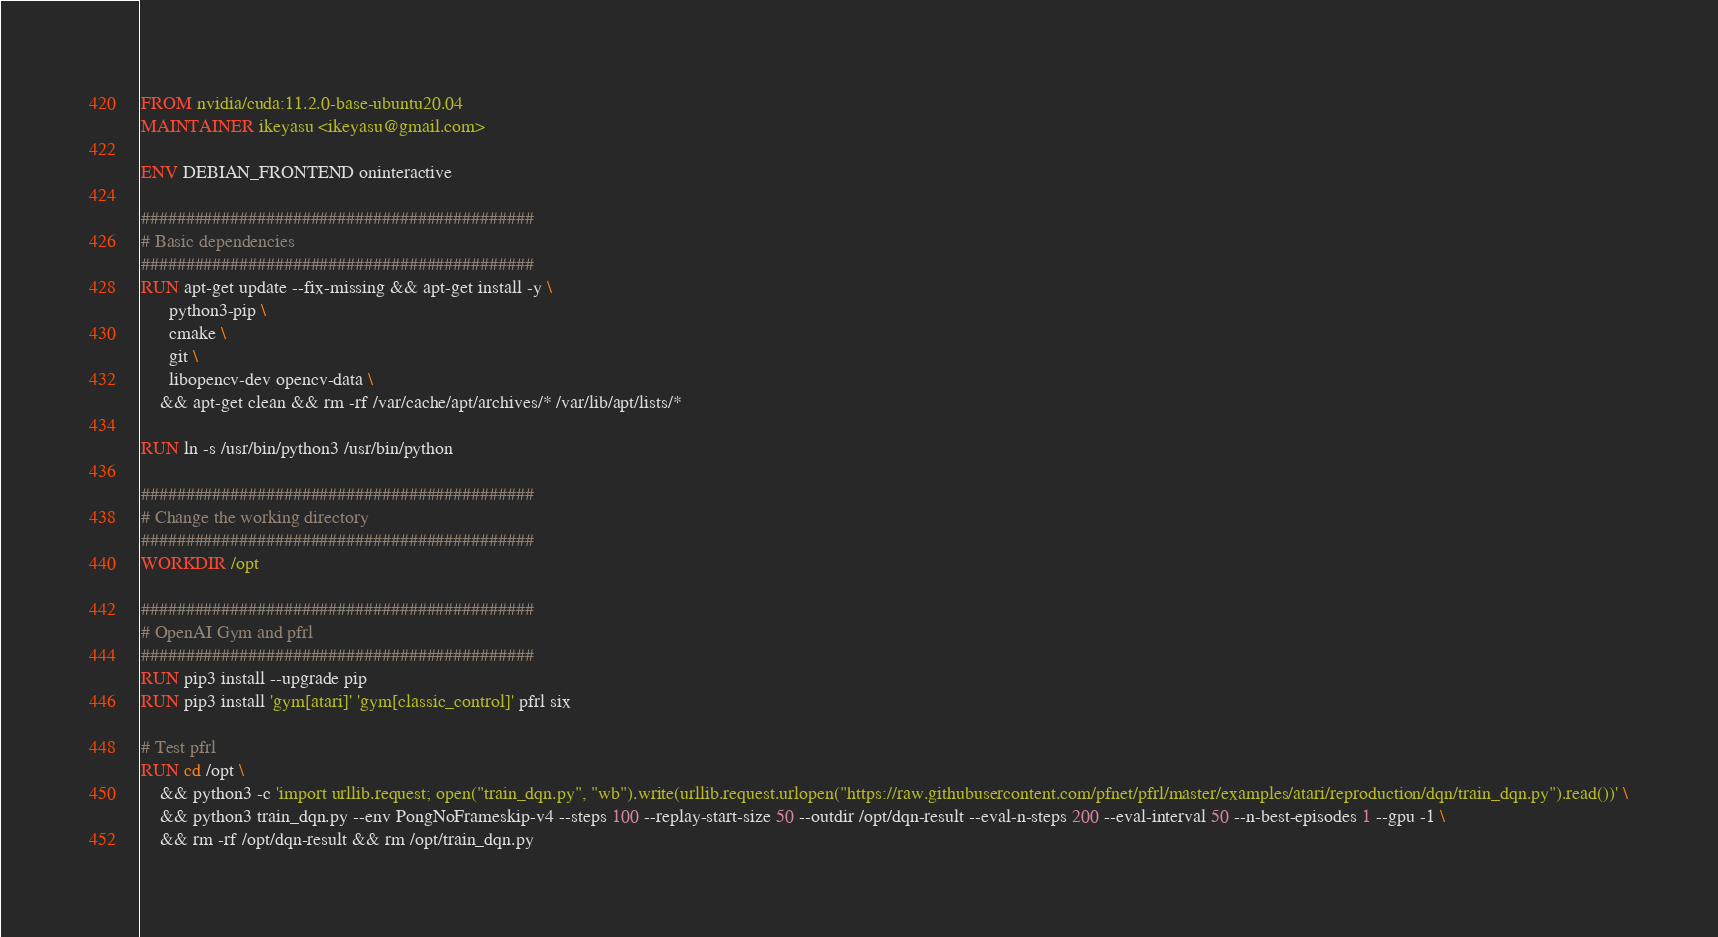<code> <loc_0><loc_0><loc_500><loc_500><_Dockerfile_>FROM nvidia/cuda:11.2.0-base-ubuntu20.04
MAINTAINER ikeyasu <ikeyasu@gmail.com>

ENV DEBIAN_FRONTEND oninteractive

############################################
# Basic dependencies
############################################
RUN apt-get update --fix-missing && apt-get install -y \
      python3-pip \
      cmake \
      git \
      libopencv-dev opencv-data \
    && apt-get clean && rm -rf /var/cache/apt/archives/* /var/lib/apt/lists/*

RUN ln -s /usr/bin/python3 /usr/bin/python

############################################
# Change the working directory
############################################
WORKDIR /opt

############################################
# OpenAI Gym and pfrl 
############################################
RUN pip3 install --upgrade pip
RUN pip3 install 'gym[atari]' 'gym[classic_control]' pfrl six

# Test pfrl
RUN cd /opt \
    && python3 -c 'import urllib.request; open("train_dqn.py", "wb").write(urllib.request.urlopen("https://raw.githubusercontent.com/pfnet/pfrl/master/examples/atari/reproduction/dqn/train_dqn.py").read())' \
    && python3 train_dqn.py --env PongNoFrameskip-v4 --steps 100 --replay-start-size 50 --outdir /opt/dqn-result --eval-n-steps 200 --eval-interval 50 --n-best-episodes 1 --gpu -1 \
    && rm -rf /opt/dqn-result && rm /opt/train_dqn.py
</code> 